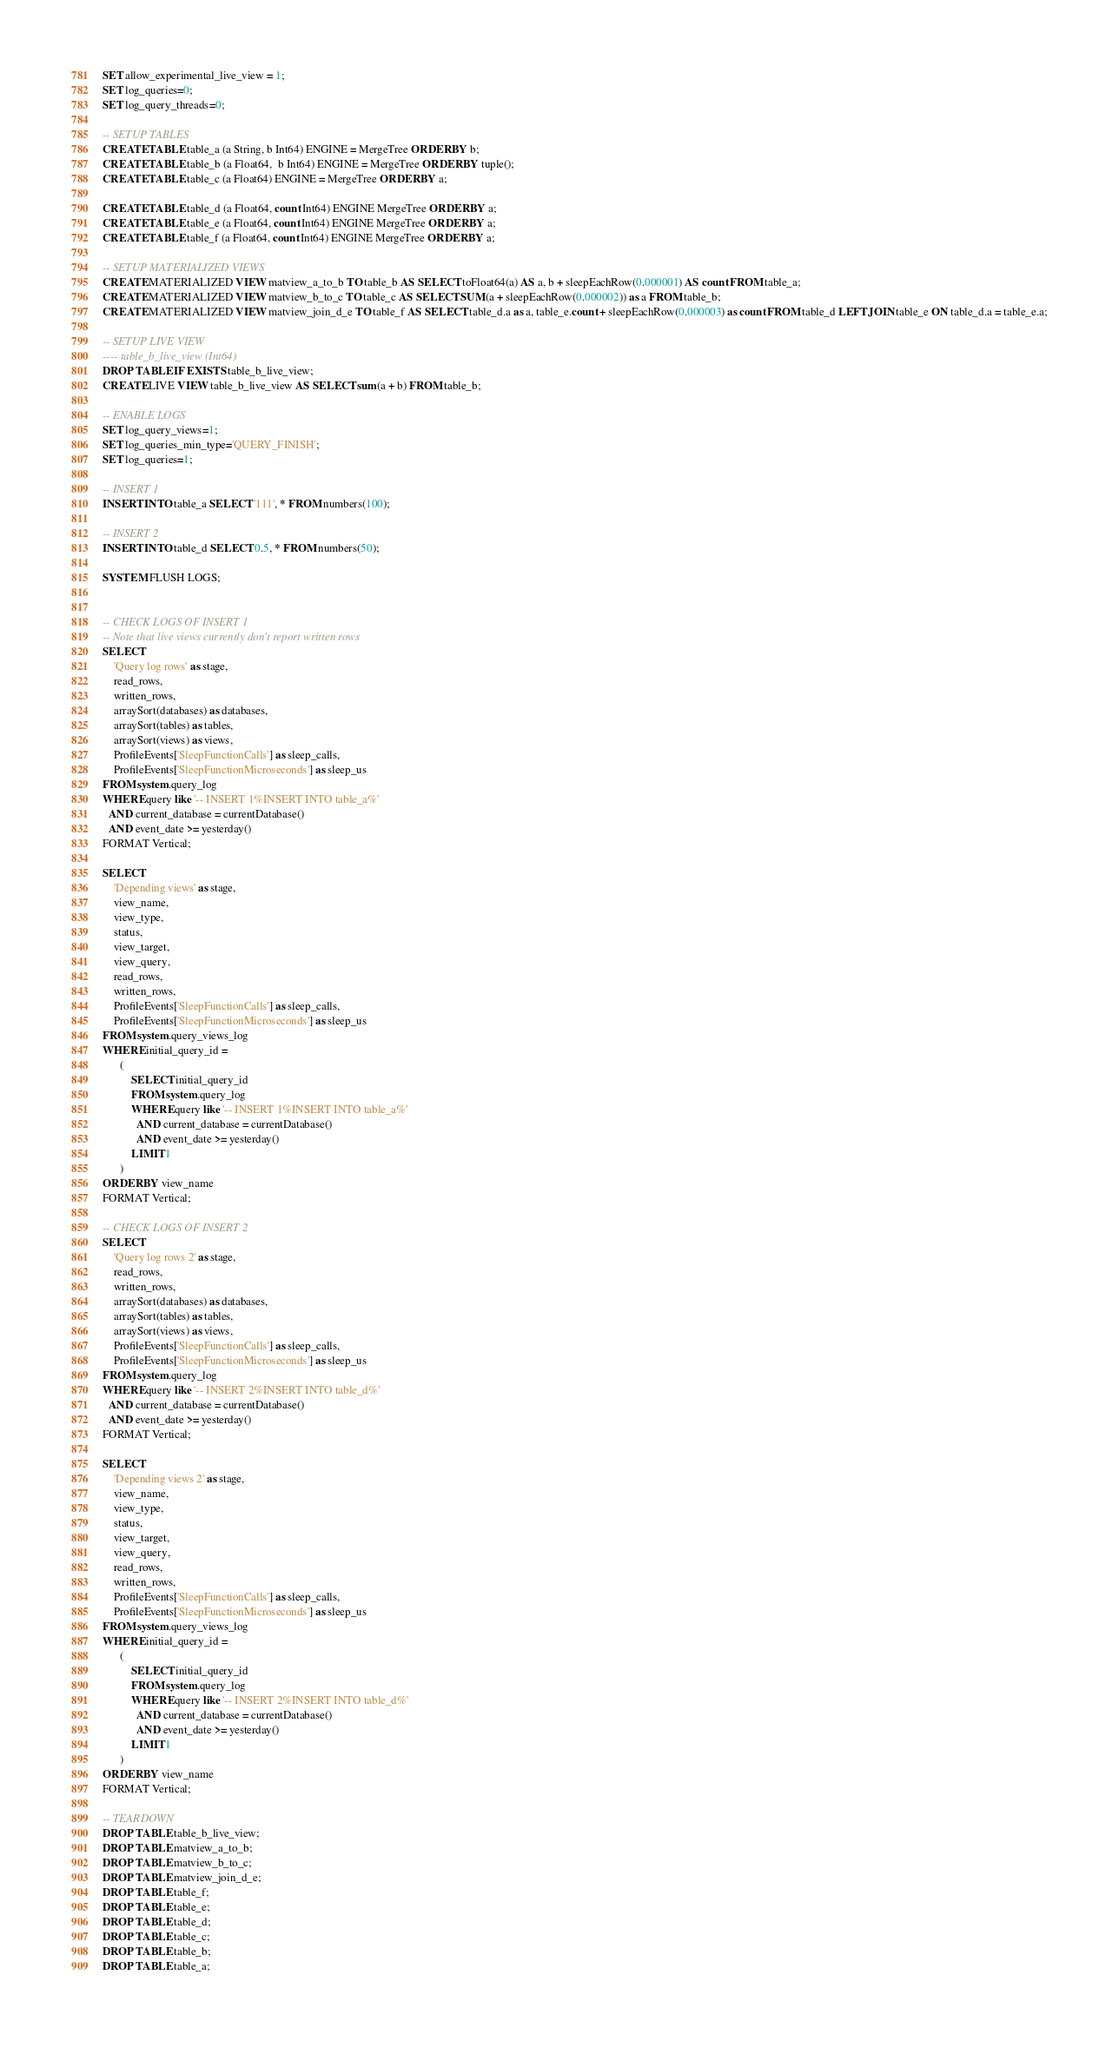<code> <loc_0><loc_0><loc_500><loc_500><_SQL_>SET allow_experimental_live_view = 1;
SET log_queries=0;
SET log_query_threads=0;

-- SETUP TABLES
CREATE TABLE table_a (a String, b Int64) ENGINE = MergeTree ORDER BY b;
CREATE TABLE table_b (a Float64,  b Int64) ENGINE = MergeTree ORDER BY tuple();
CREATE TABLE table_c (a Float64) ENGINE = MergeTree ORDER BY a;

CREATE TABLE table_d (a Float64, count Int64) ENGINE MergeTree ORDER BY a;
CREATE TABLE table_e (a Float64, count Int64) ENGINE MergeTree ORDER BY a;
CREATE TABLE table_f (a Float64, count Int64) ENGINE MergeTree ORDER BY a;

-- SETUP MATERIALIZED VIEWS
CREATE MATERIALIZED VIEW matview_a_to_b TO table_b AS SELECT toFloat64(a) AS a, b + sleepEachRow(0.000001) AS count FROM table_a;
CREATE MATERIALIZED VIEW matview_b_to_c TO table_c AS SELECT SUM(a + sleepEachRow(0.000002)) as a FROM table_b;
CREATE MATERIALIZED VIEW matview_join_d_e TO table_f AS SELECT table_d.a as a, table_e.count + sleepEachRow(0.000003) as count FROM table_d LEFT JOIN table_e ON table_d.a = table_e.a;

-- SETUP LIVE VIEW
---- table_b_live_view (Int64)
DROP TABLE IF EXISTS table_b_live_view;
CREATE LIVE VIEW table_b_live_view AS SELECT sum(a + b) FROM table_b;

-- ENABLE LOGS
SET log_query_views=1;
SET log_queries_min_type='QUERY_FINISH';
SET log_queries=1;

-- INSERT 1
INSERT INTO table_a SELECT '111', * FROM numbers(100);

-- INSERT 2
INSERT INTO table_d SELECT 0.5, * FROM numbers(50);

SYSTEM FLUSH LOGS;


-- CHECK LOGS OF INSERT 1
-- Note that live views currently don't report written rows
SELECT
    'Query log rows' as stage,
    read_rows,
    written_rows,
    arraySort(databases) as databases,
    arraySort(tables) as tables,
    arraySort(views) as views,
    ProfileEvents['SleepFunctionCalls'] as sleep_calls,
    ProfileEvents['SleepFunctionMicroseconds'] as sleep_us
FROM system.query_log
WHERE query like '-- INSERT 1%INSERT INTO table_a%'
  AND current_database = currentDatabase()
  AND event_date >= yesterday()
FORMAT Vertical;

SELECT
    'Depending views' as stage,
    view_name,
    view_type,
    status,
    view_target,
    view_query,
    read_rows,
    written_rows,
    ProfileEvents['SleepFunctionCalls'] as sleep_calls,
    ProfileEvents['SleepFunctionMicroseconds'] as sleep_us
FROM system.query_views_log
WHERE initial_query_id =
      (
          SELECT initial_query_id
          FROM system.query_log
          WHERE query like '-- INSERT 1%INSERT INTO table_a%'
            AND current_database = currentDatabase()
            AND event_date >= yesterday()
          LIMIT 1
      )
ORDER BY view_name
FORMAT Vertical;

-- CHECK LOGS OF INSERT 2
SELECT
    'Query log rows 2' as stage,
    read_rows,
    written_rows,
    arraySort(databases) as databases,
    arraySort(tables) as tables,
    arraySort(views) as views,
    ProfileEvents['SleepFunctionCalls'] as sleep_calls,
    ProfileEvents['SleepFunctionMicroseconds'] as sleep_us
FROM system.query_log
WHERE query like '-- INSERT 2%INSERT INTO table_d%'
  AND current_database = currentDatabase()
  AND event_date >= yesterday()
FORMAT Vertical;

SELECT
    'Depending views 2' as stage,
    view_name,
    view_type,
    status,
    view_target,
    view_query,
    read_rows,
    written_rows,
    ProfileEvents['SleepFunctionCalls'] as sleep_calls,
    ProfileEvents['SleepFunctionMicroseconds'] as sleep_us
FROM system.query_views_log
WHERE initial_query_id =
      (
          SELECT initial_query_id
          FROM system.query_log
          WHERE query like '-- INSERT 2%INSERT INTO table_d%'
            AND current_database = currentDatabase()
            AND event_date >= yesterday()
          LIMIT 1
      )
ORDER BY view_name
FORMAT Vertical;

-- TEARDOWN
DROP TABLE table_b_live_view;
DROP TABLE matview_a_to_b;
DROP TABLE matview_b_to_c;
DROP TABLE matview_join_d_e;
DROP TABLE table_f;
DROP TABLE table_e;
DROP TABLE table_d;
DROP TABLE table_c;
DROP TABLE table_b;
DROP TABLE table_a;
</code> 